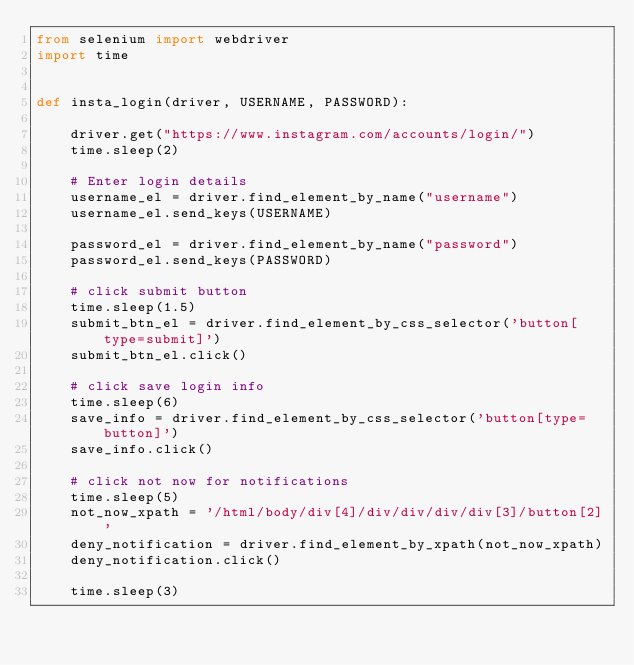<code> <loc_0><loc_0><loc_500><loc_500><_Python_>from selenium import webdriver
import time


def insta_login(driver, USERNAME, PASSWORD):

    driver.get("https://www.instagram.com/accounts/login/")
    time.sleep(2)

    # Enter login details
    username_el = driver.find_element_by_name("username")
    username_el.send_keys(USERNAME)

    password_el = driver.find_element_by_name("password")
    password_el.send_keys(PASSWORD)

    # click submit button
    time.sleep(1.5)
    submit_btn_el = driver.find_element_by_css_selector('button[type=submit]')
    submit_btn_el.click()

    # click save login info
    time.sleep(6)
    save_info = driver.find_element_by_css_selector('button[type=button]')
    save_info.click()

    # click not now for notifications
    time.sleep(5)
    not_now_xpath = '/html/body/div[4]/div/div/div/div[3]/button[2]'
    deny_notification = driver.find_element_by_xpath(not_now_xpath)
    deny_notification.click()

    time.sleep(3)








</code> 